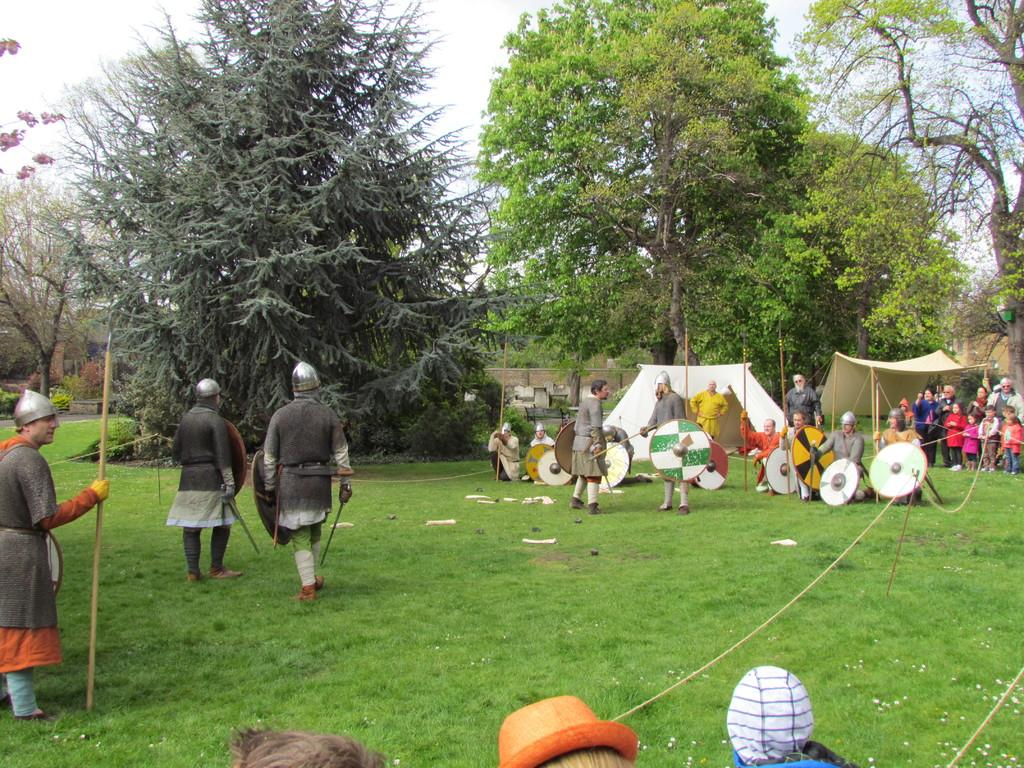How many people are in the image? There are people in the image, but the exact number is not specified. Where are the people located in the image? The people are on the grass in the image. What are some people doing in the image? Some people are holding objects in the image. What can be seen in the background of the image? In the background of the image, there are plants, trees, a wall, tents, and the sky. What advertisement can be seen on the wall in the image? There is no advertisement visible on the wall in the image. What suggestion can be made to the people in the image to avoid trouble? There is no indication of trouble in the image, and therefore no suggestion can be made based on the information provided. 